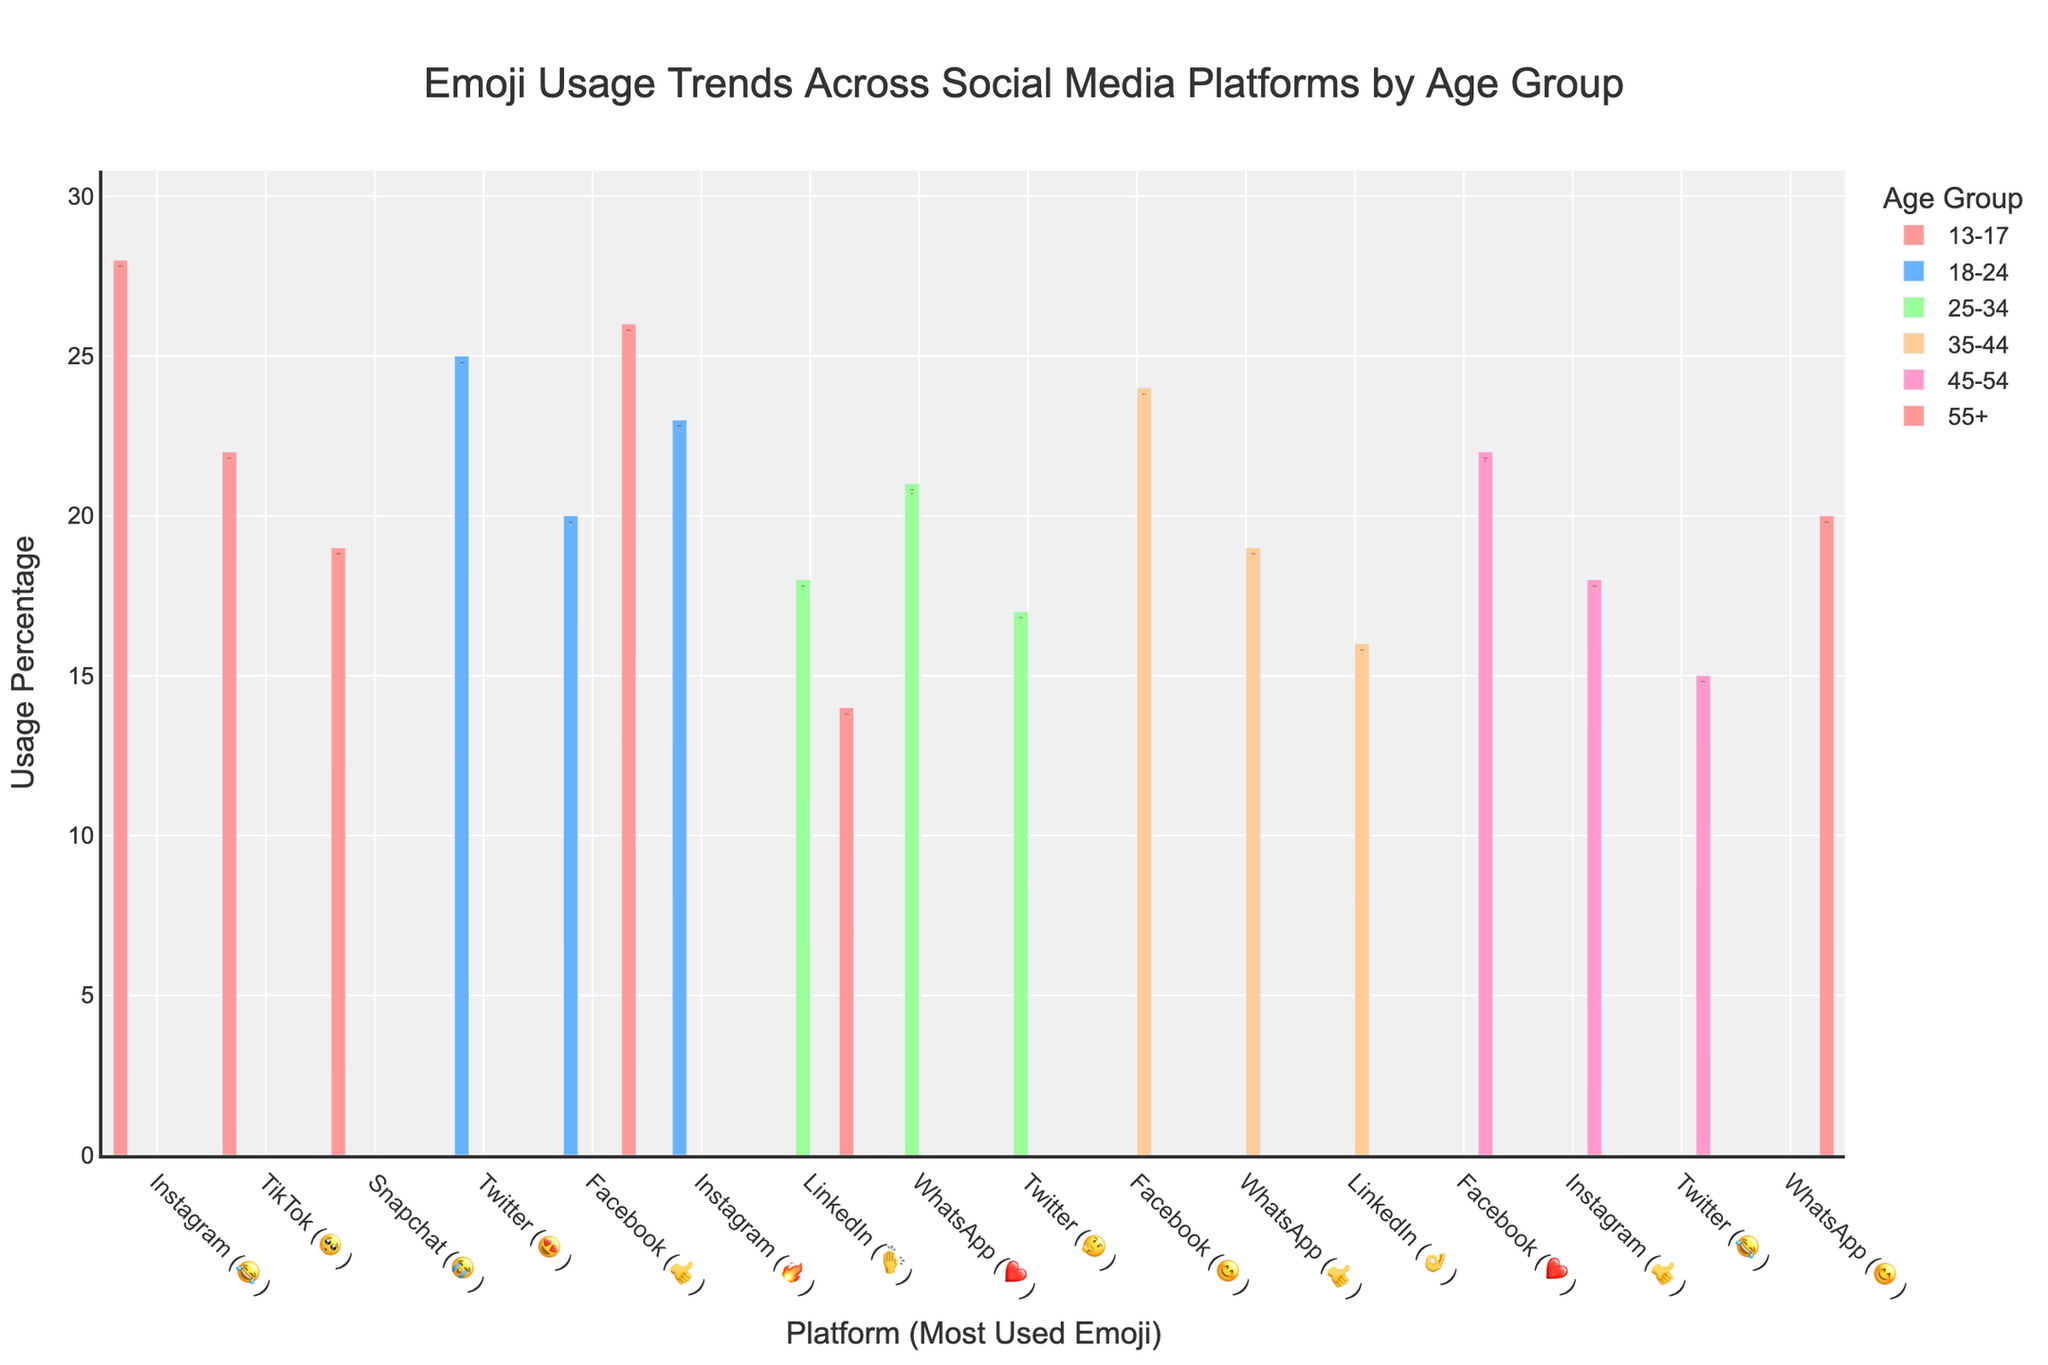Which age group uses the 😂 emoji the most? Look for the highest usage percentage of the 😂 emoji across all age groups. The 13-17 age group on Instagram uses 😂 the most at 28%.
Answer: 13-17 What's the most used emoji on Twitter by the 45-54 age group? Identify the emoji used on the Twitter bar for the 45-54 age group. It's 😂 with a 15% usage rate.
Answer: 😂 Which platform has the highest usage percentage of the 👍 emoji? Compare all usage percentages of the 👍 emoji across different age groups and platforms. The 55+ age group on Facebook has the highest at 26%.
Answer: Facebook (55+) What is the average usage percentage of emojis on LinkedIn across age groups? Add the usage percentages of emojis on LinkedIn (18 + 16 + 14) and divide by the three age groups (25-34, 35-44, 55+). The average is (18+16+14) / 3 = 16%.
Answer: 16% How does emoji usage on Facebook differ for the 18-24 and 35-44 age groups? Compare the Facebook usage percentages and emojis for the two age groups. The 18-24 age group uses 👍 at 20%, while the 35-44 age group uses 😊 at 24%.
Answer: 20% 👍 vs. 24% 😊 Which age group has the most diverse emoji usage across different platforms? Determine each age group's range of most used emojis across platforms. The 25-34 age group uses 👏, ❤️, and 🤔 across LinkedIn, WhatsApp, and Twitter.
Answer: 25-34 What is the total usage percentage of the ❤️ emoji across all age groups? Add the usage percentages of the ❤️ emoji for the 25-34 (WhatsApp 21%), 45-54 (Facebook 22%), and calculate the total. The sum is 21+22 = 43%.
Answer: 43% Which age group's most used emoji changes the most frequently across platforms according to the figure? Compare the most used emojis for each age group across platforms to see changes. The 25-34 age group has three different emojis (👏, ❤️, 🤔) across LinkedIn, WhatsApp, and Twitter.
Answer: 25-34 From the figure, which emoji is equally used on Facebook and WhatsApp by different age groups? Look for emojis with the same usage percentage on Facebook and WhatsApp by different age groups. The ❤️ emoji is used by the 45-54 age group on Facebook (22%) and the 25-34 age group on WhatsApp (21%).
Answer: ❤️ 